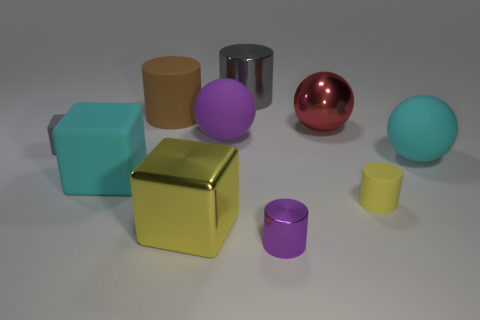There is a purple thing on the right side of the large gray object; what material is it?
Offer a very short reply. Metal. Is the number of cyan objects less than the number of purple metallic cylinders?
Provide a succinct answer. No. What is the size of the cylinder that is both behind the tiny shiny cylinder and in front of the shiny sphere?
Keep it short and to the point. Small. What is the size of the cyan matte object that is on the left side of the yellow thing right of the purple shiny cylinder on the right side of the yellow cube?
Provide a succinct answer. Large. How many other things are there of the same color as the large metallic cylinder?
Offer a very short reply. 1. Do the metallic object that is on the left side of the big purple matte ball and the small rubber cylinder have the same color?
Offer a terse response. Yes. What number of objects are either big brown metal cylinders or large cyan matte things?
Keep it short and to the point. 2. The matte sphere to the left of the big gray thing is what color?
Give a very brief answer. Purple. Are there fewer brown cylinders in front of the small yellow object than large gray matte spheres?
Provide a short and direct response. No. What size is the rubber cube that is the same color as the big metal cylinder?
Your answer should be very brief. Small. 